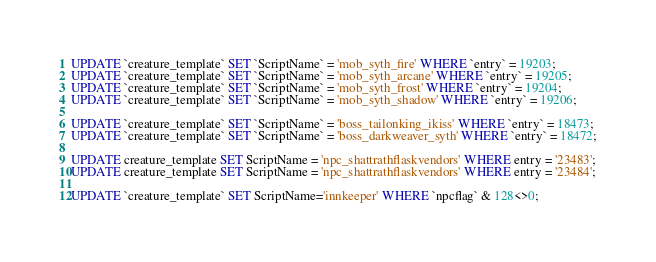<code> <loc_0><loc_0><loc_500><loc_500><_SQL_>UPDATE `creature_template` SET `ScriptName` = 'mob_syth_fire' WHERE `entry` = 19203;
UPDATE `creature_template` SET `ScriptName` = 'mob_syth_arcane' WHERE `entry` = 19205;
UPDATE `creature_template` SET `ScriptName` = 'mob_syth_frost' WHERE `entry` = 19204;
UPDATE `creature_template` SET `ScriptName` = 'mob_syth_shadow' WHERE `entry` = 19206;

UPDATE `creature_template` SET `ScriptName` = 'boss_tailonking_ikiss' WHERE `entry` = 18473;
UPDATE `creature_template` SET `ScriptName` = 'boss_darkweaver_syth' WHERE `entry` = 18472;

UPDATE creature_template SET ScriptName = 'npc_shattrathflaskvendors' WHERE entry = '23483';
UPDATE creature_template SET ScriptName = 'npc_shattrathflaskvendors' WHERE entry = '23484';

UPDATE `creature_template` SET ScriptName='innkeeper' WHERE `npcflag` & 128<>0;
</code> 